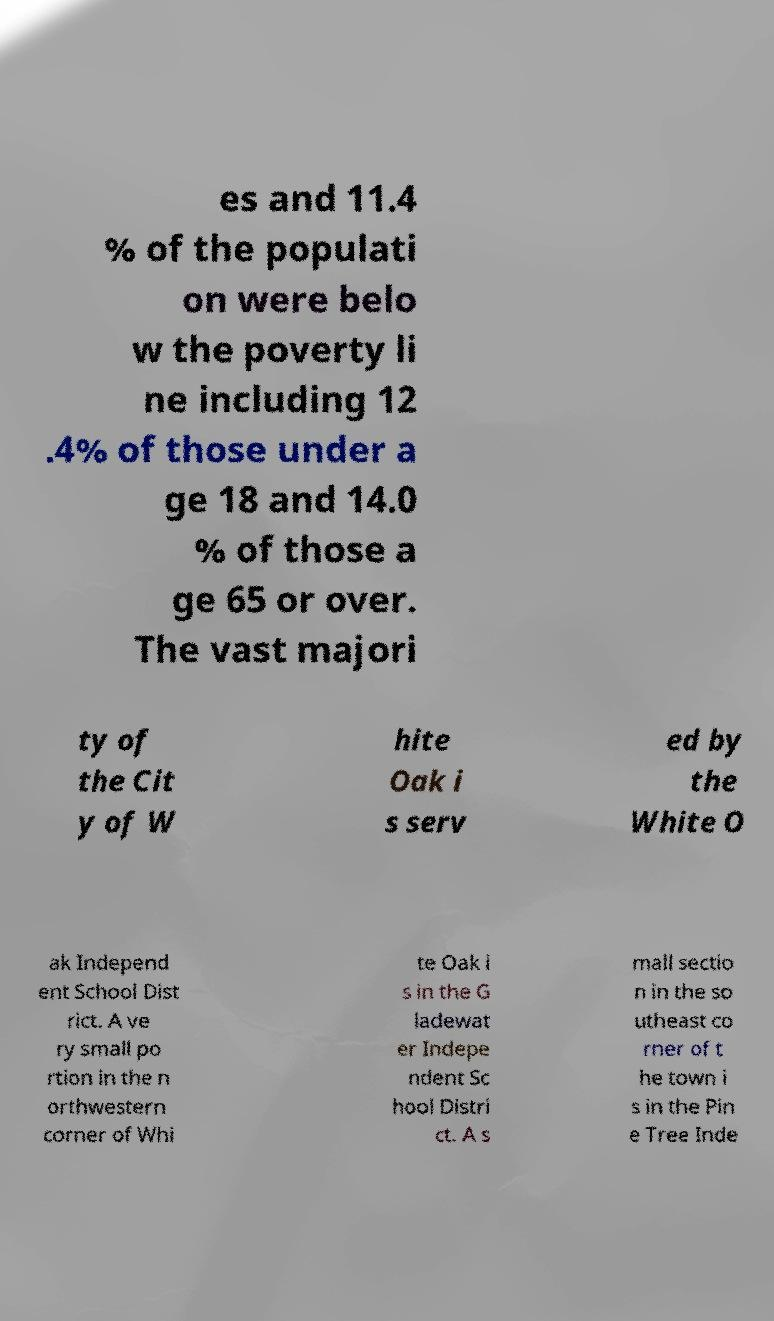Please identify and transcribe the text found in this image. es and 11.4 % of the populati on were belo w the poverty li ne including 12 .4% of those under a ge 18 and 14.0 % of those a ge 65 or over. The vast majori ty of the Cit y of W hite Oak i s serv ed by the White O ak Independ ent School Dist rict. A ve ry small po rtion in the n orthwestern corner of Whi te Oak i s in the G ladewat er Indepe ndent Sc hool Distri ct. A s mall sectio n in the so utheast co rner of t he town i s in the Pin e Tree Inde 